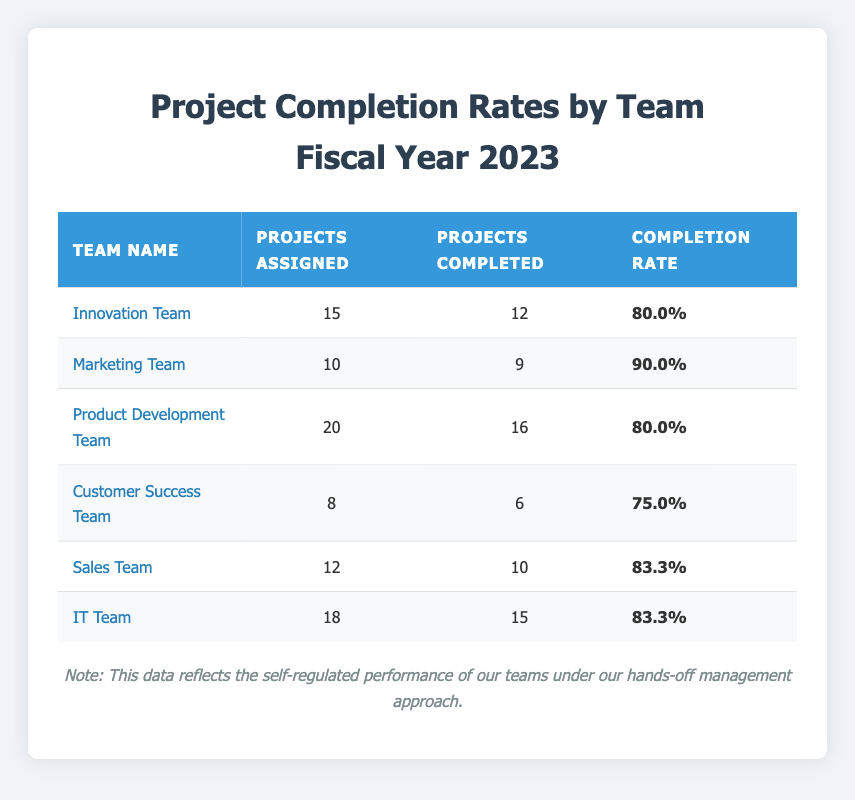What is the completion rate of the Marketing Team? The completion rate for the Marketing Team is listed directly in the table under the "Completion Rate" column, showing 90.0%.
Answer: 90.0% Which team completed the most projects? To find the team that completed the most projects, we look under the "Projects Completed" column and see that the Product Development Team completed 16 projects, which is the highest number.
Answer: Product Development Team What is the average completion rate of all teams? To calculate the average, we add all the completion rates: 80.0 + 90.0 + 80.0 + 75.0 + 83.3 + 83.3 = 491.6. Then we divide by the number of teams: 491.6 / 6 = 81.93.
Answer: 81.93 Did the IT Team and Sales Team have the same completion rate? By checking their completion rates in the table, IT Team's rate is 83.3% and Sales Team's rate is also 83.3%. They are equal, thus the answer is yes.
Answer: Yes Which team has the lowest completion rate? The lowest completion rate can be found by comparing all rates in the "Completion Rate" column. The Customer Success Team has a completion rate of 75.0%, which is the lowest compared to others.
Answer: Customer Success Team How many total projects were completed across all teams? To find the total completed projects, we add the numbers from the "Projects Completed" column: 12 + 9 + 16 + 6 + 10 + 15 = 68.
Answer: 68 If teams are categorized into two groups based on their completion rates above and below 80%, how many fall into each group? First, we identify the teams above 80%: Marketing Team, Sales Team, and IT Team (3 teams). Then, below 80%: Innovation Team, Product Development Team, and Customer Success Team (3 teams). Both groups have the same number of teams.
Answer: 3 each What percentage of the total projects assigned was completed? First, we find the total projects assigned: 15 + 10 + 20 + 8 + 12 + 18 = 93. Then, total completed projects were 68. The percentage completed is (68 / 93) * 100 = 73.17%.
Answer: 73.17% Is it true that the Innovation Team completed more than 80% of their assigned projects? The completion rate for the Innovation Team is explicitly listed in the table as 80.0%. Since this is not greater than 80%, the statement is false.
Answer: No 